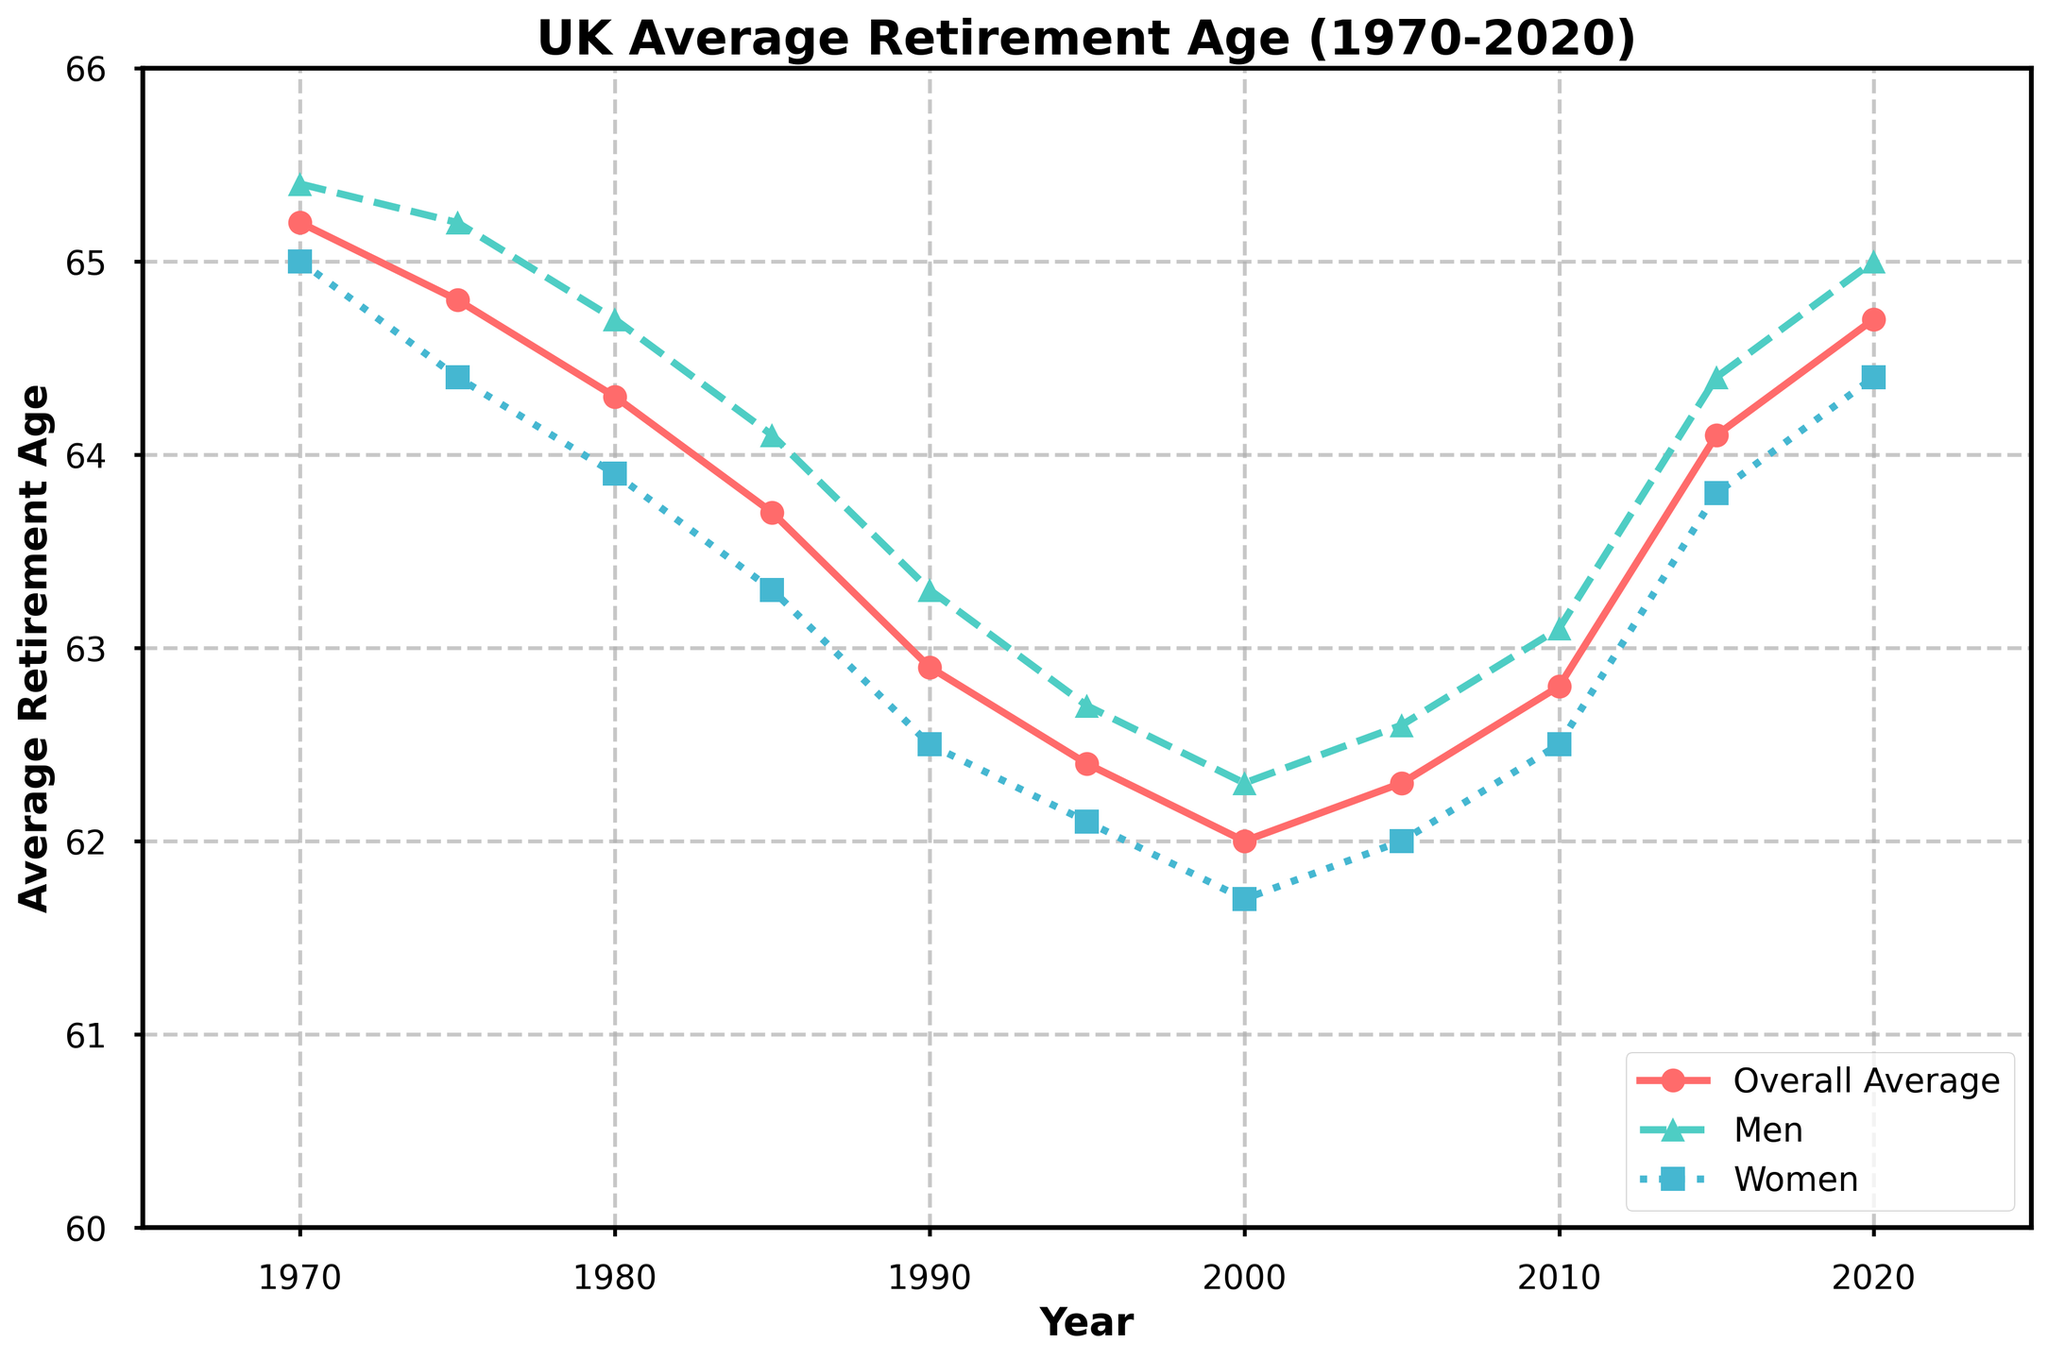What is the overall trend in the average retirement age from 1970 to 2020? The overall average retirement age decreases from 1970 to 2000 and then starts to increase steadily until 2020.
Answer: Decreases, then increases How does the average retirement age for men in 2020 compare to that in 1970? In 1970, the average retirement age for men is 65.4 years, while in 2020, it is 65.0 years.
Answer: Decreased Which gender had a lower average retirement age in 1985? In 1985, the average retirement age for men is 64.1 years, and for women, it is 63.3 years.
Answer: Women By how much did the average retirement age for women increase from 1990 to 2020? The average retirement age for women in 1990 is 62.5 years, and in 2020, it is 64.4 years. The increase is 64.4 - 62.5 = 1.9 years.
Answer: 1.9 years What is the difference between the average retirement age for men and women in 2015? In 2015, the average retirement age for men is 64.4 years, and for women, it is 63.8 years. The difference is 64.4 - 63.8 = 0.6 years.
Answer: 0.6 years In which year did the overall average retirement age reach a minimum, based on the chart? The overall average retirement age reaches a minimum in 2000, with a value of 62.0 years.
Answer: 2000 Compare the visual markers used to differentiate the retirement ages for men and women in the plot. The plot uses different visual markers for men and women: triangles for men and squares for women.
Answer: Triangles for men, squares for women In which year is the gap between men’s and women’s average retirement ages largest? The largest gap, based on visual inspection, appears to be in 1980, where men have an average retirement age of 64.7 years and women 63.9 years. The gap is 64.7 - 63.9 = 0.8 years.
Answer: 1980 How did the overall average retirement age change between 2000 and 2010? The overall average retirement age increased from 62.0 years in 2000 to 62.8 years in 2010.
Answer: Increased 